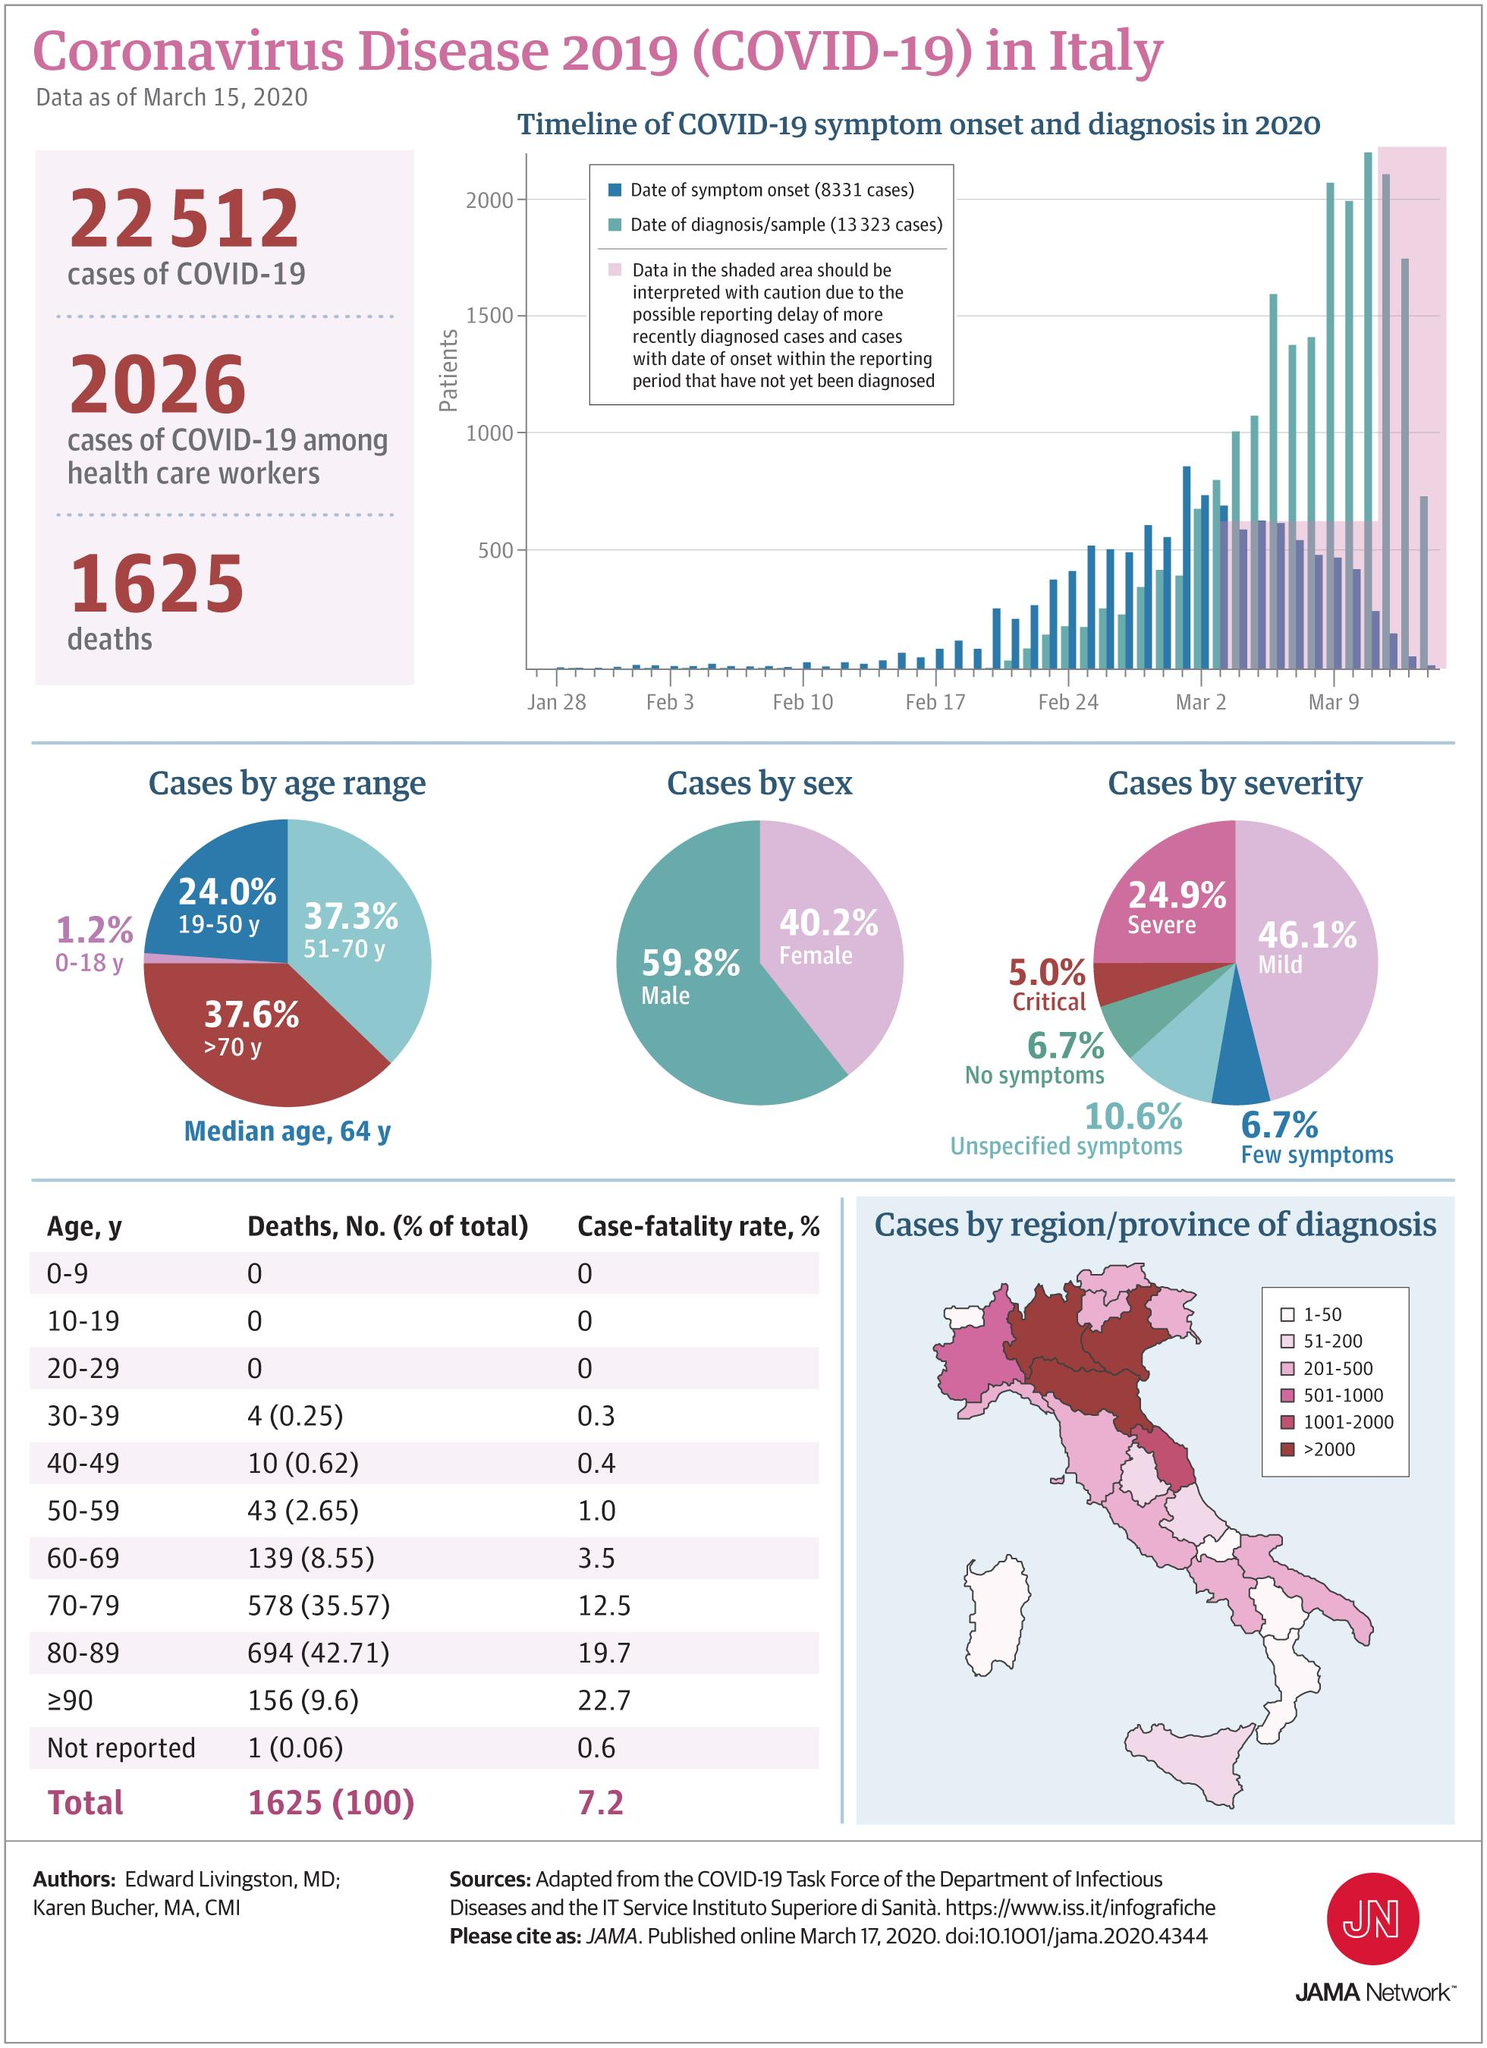Specify some key components in this picture. As of March 15, 2020, a total of 1,625 Covid-19 deaths had been reported in Italy. As of March 15, 2020, the case fatality rate of Covid-19 in the age group of 50-59 years in Italy was 1.0. According to data as of March 15, 2020, the age group most affected by COVID-19 in Italy was individuals over 70 years old. As of March 15, 2020, it was reported that 59.8% of the infected people in Italy were male. As of March 15, 2020, approximately 5.0% of people in Italy have exhibited critical symptoms of COVID-19. 